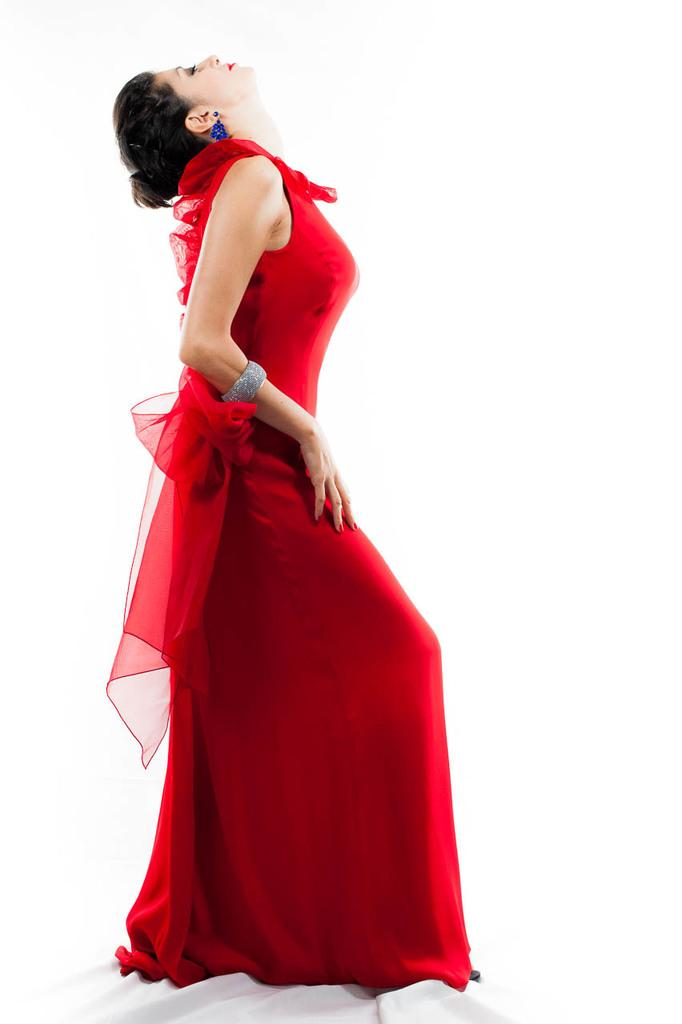Who is the main subject in the image? There is a lady in the image. What is the lady wearing? The lady is wearing a red dress. What color is the background of the image? The background of the image is white. Can you see any wings on the lady in the image? No, there are no wings visible on the lady in the image. 